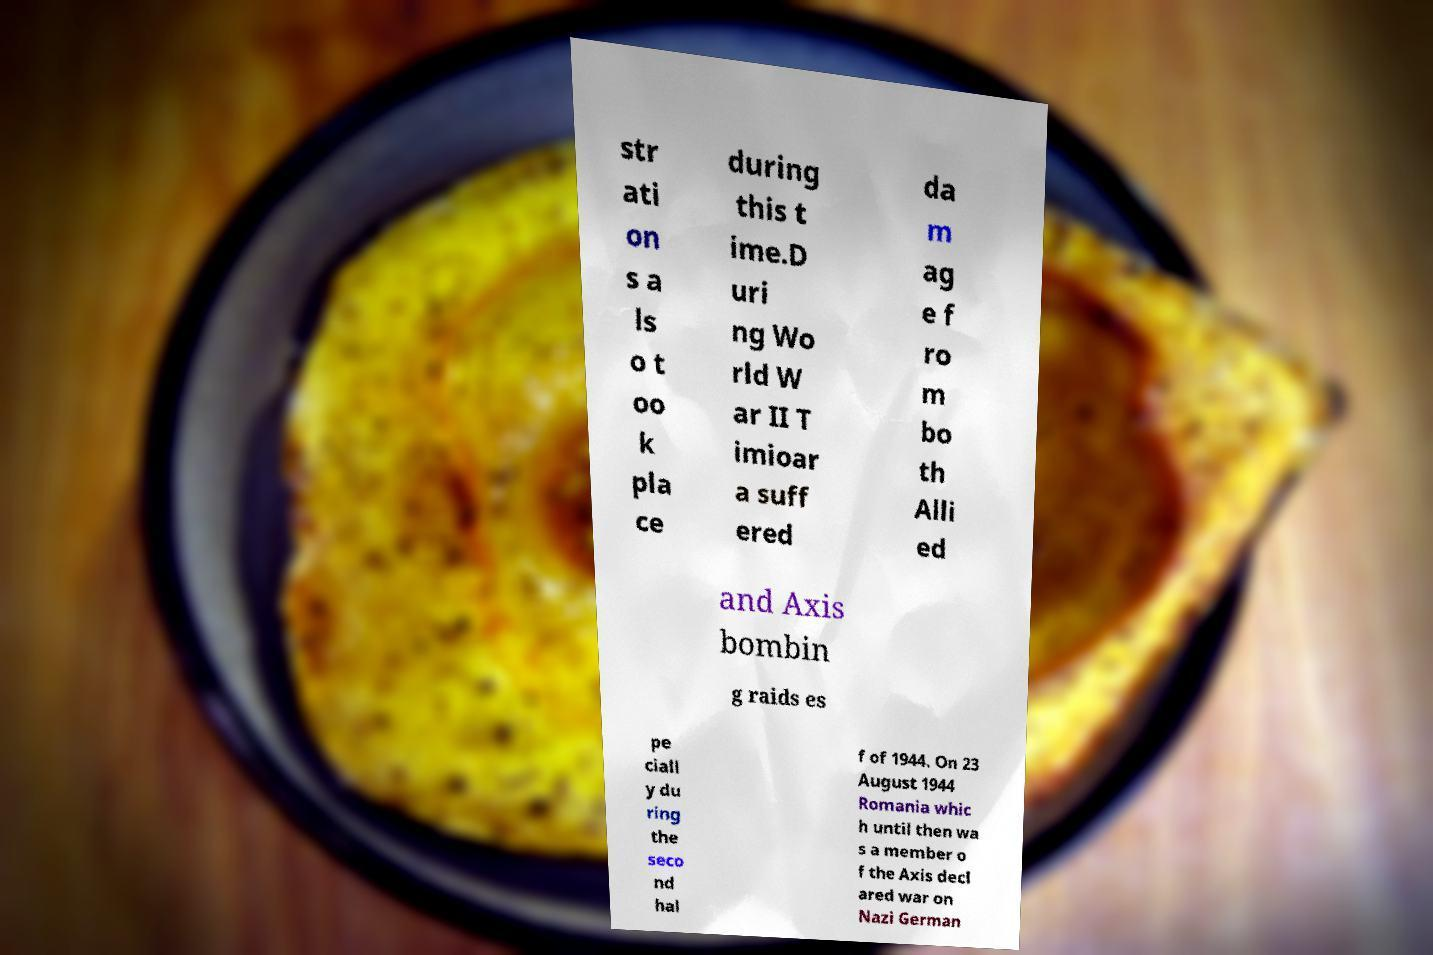There's text embedded in this image that I need extracted. Can you transcribe it verbatim? str ati on s a ls o t oo k pla ce during this t ime.D uri ng Wo rld W ar II T imioar a suff ered da m ag e f ro m bo th Alli ed and Axis bombin g raids es pe ciall y du ring the seco nd hal f of 1944. On 23 August 1944 Romania whic h until then wa s a member o f the Axis decl ared war on Nazi German 